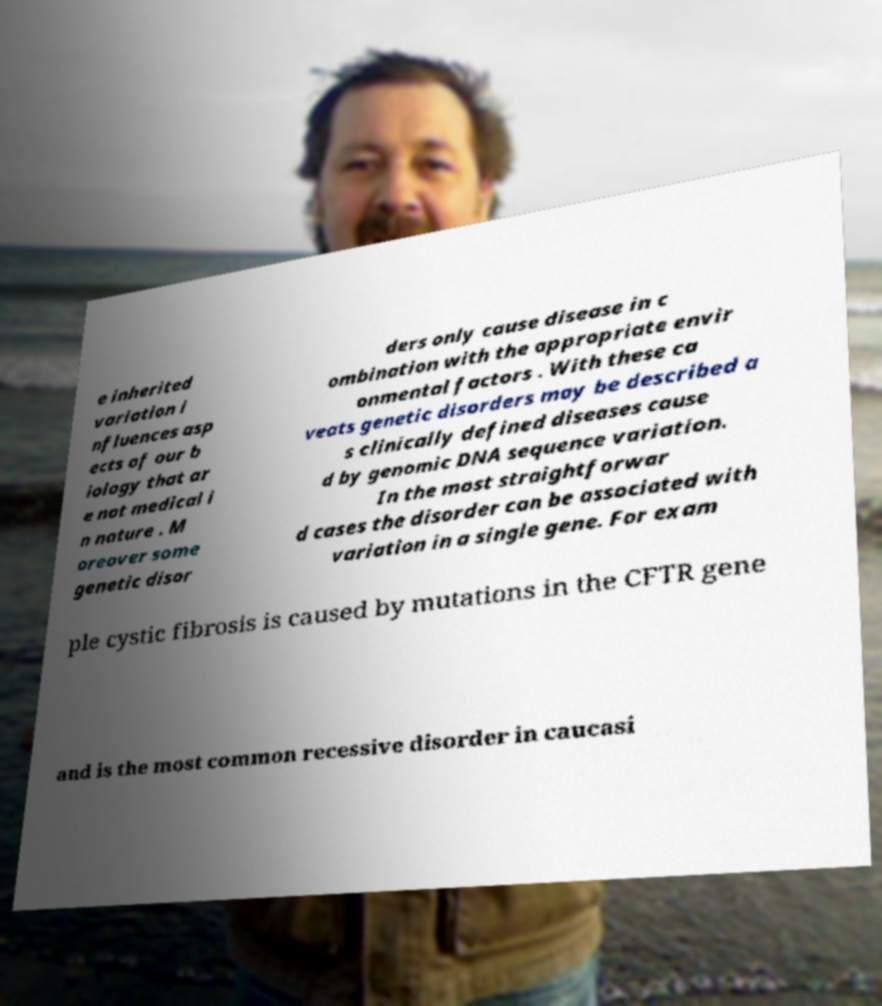What messages or text are displayed in this image? I need them in a readable, typed format. e inherited variation i nfluences asp ects of our b iology that ar e not medical i n nature . M oreover some genetic disor ders only cause disease in c ombination with the appropriate envir onmental factors . With these ca veats genetic disorders may be described a s clinically defined diseases cause d by genomic DNA sequence variation. In the most straightforwar d cases the disorder can be associated with variation in a single gene. For exam ple cystic fibrosis is caused by mutations in the CFTR gene and is the most common recessive disorder in caucasi 